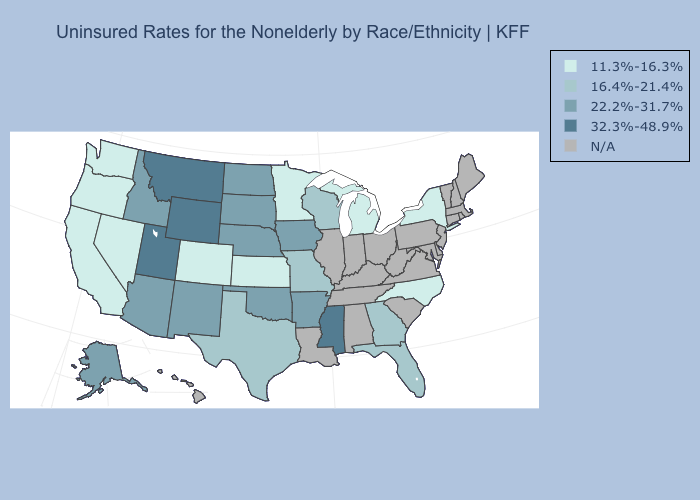What is the lowest value in states that border Pennsylvania?
Keep it brief. 11.3%-16.3%. Which states have the highest value in the USA?
Answer briefly. Mississippi, Montana, Utah, Wyoming. Does the map have missing data?
Keep it brief. Yes. Among the states that border Wisconsin , which have the highest value?
Quick response, please. Iowa. What is the value of Montana?
Keep it brief. 32.3%-48.9%. What is the highest value in states that border Utah?
Short answer required. 32.3%-48.9%. Does Mississippi have the highest value in the USA?
Short answer required. Yes. Name the states that have a value in the range 16.4%-21.4%?
Give a very brief answer. Florida, Georgia, Missouri, Texas, Wisconsin. What is the value of Delaware?
Give a very brief answer. N/A. What is the value of Montana?
Short answer required. 32.3%-48.9%. Name the states that have a value in the range 16.4%-21.4%?
Quick response, please. Florida, Georgia, Missouri, Texas, Wisconsin. Name the states that have a value in the range N/A?
Concise answer only. Alabama, Connecticut, Delaware, Hawaii, Illinois, Indiana, Kentucky, Louisiana, Maine, Maryland, Massachusetts, New Hampshire, New Jersey, Ohio, Pennsylvania, Rhode Island, South Carolina, Tennessee, Vermont, Virginia, West Virginia. Name the states that have a value in the range 22.2%-31.7%?
Quick response, please. Alaska, Arizona, Arkansas, Idaho, Iowa, Nebraska, New Mexico, North Dakota, Oklahoma, South Dakota. How many symbols are there in the legend?
Keep it brief. 5. What is the value of Connecticut?
Be succinct. N/A. 